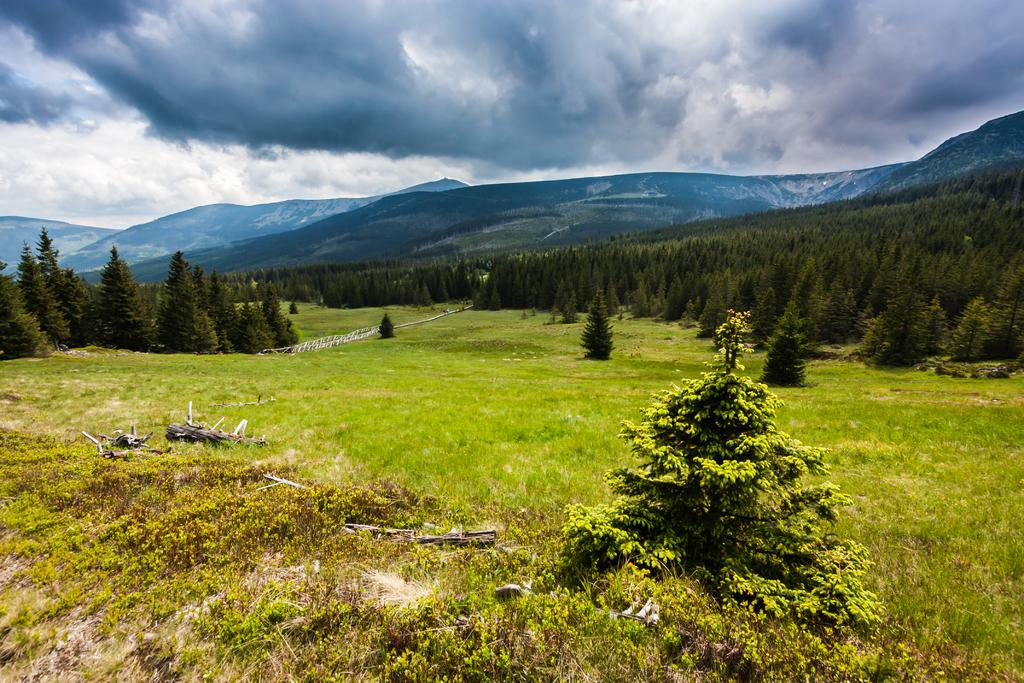What type of vegetation can be seen in the image? There is grass, plants, and trees visible in the image. What type of landscape is depicted in the image? The image features a landscape with mountains. What is visible on the ground in the image? There are objects on the ground in the image. What is visible in the sky in the image? The sky is visible in the image, and there are clouds present. What type of apparel is the teacher wearing at the event in the image? There is no teacher, apparel, or event present in the image. 